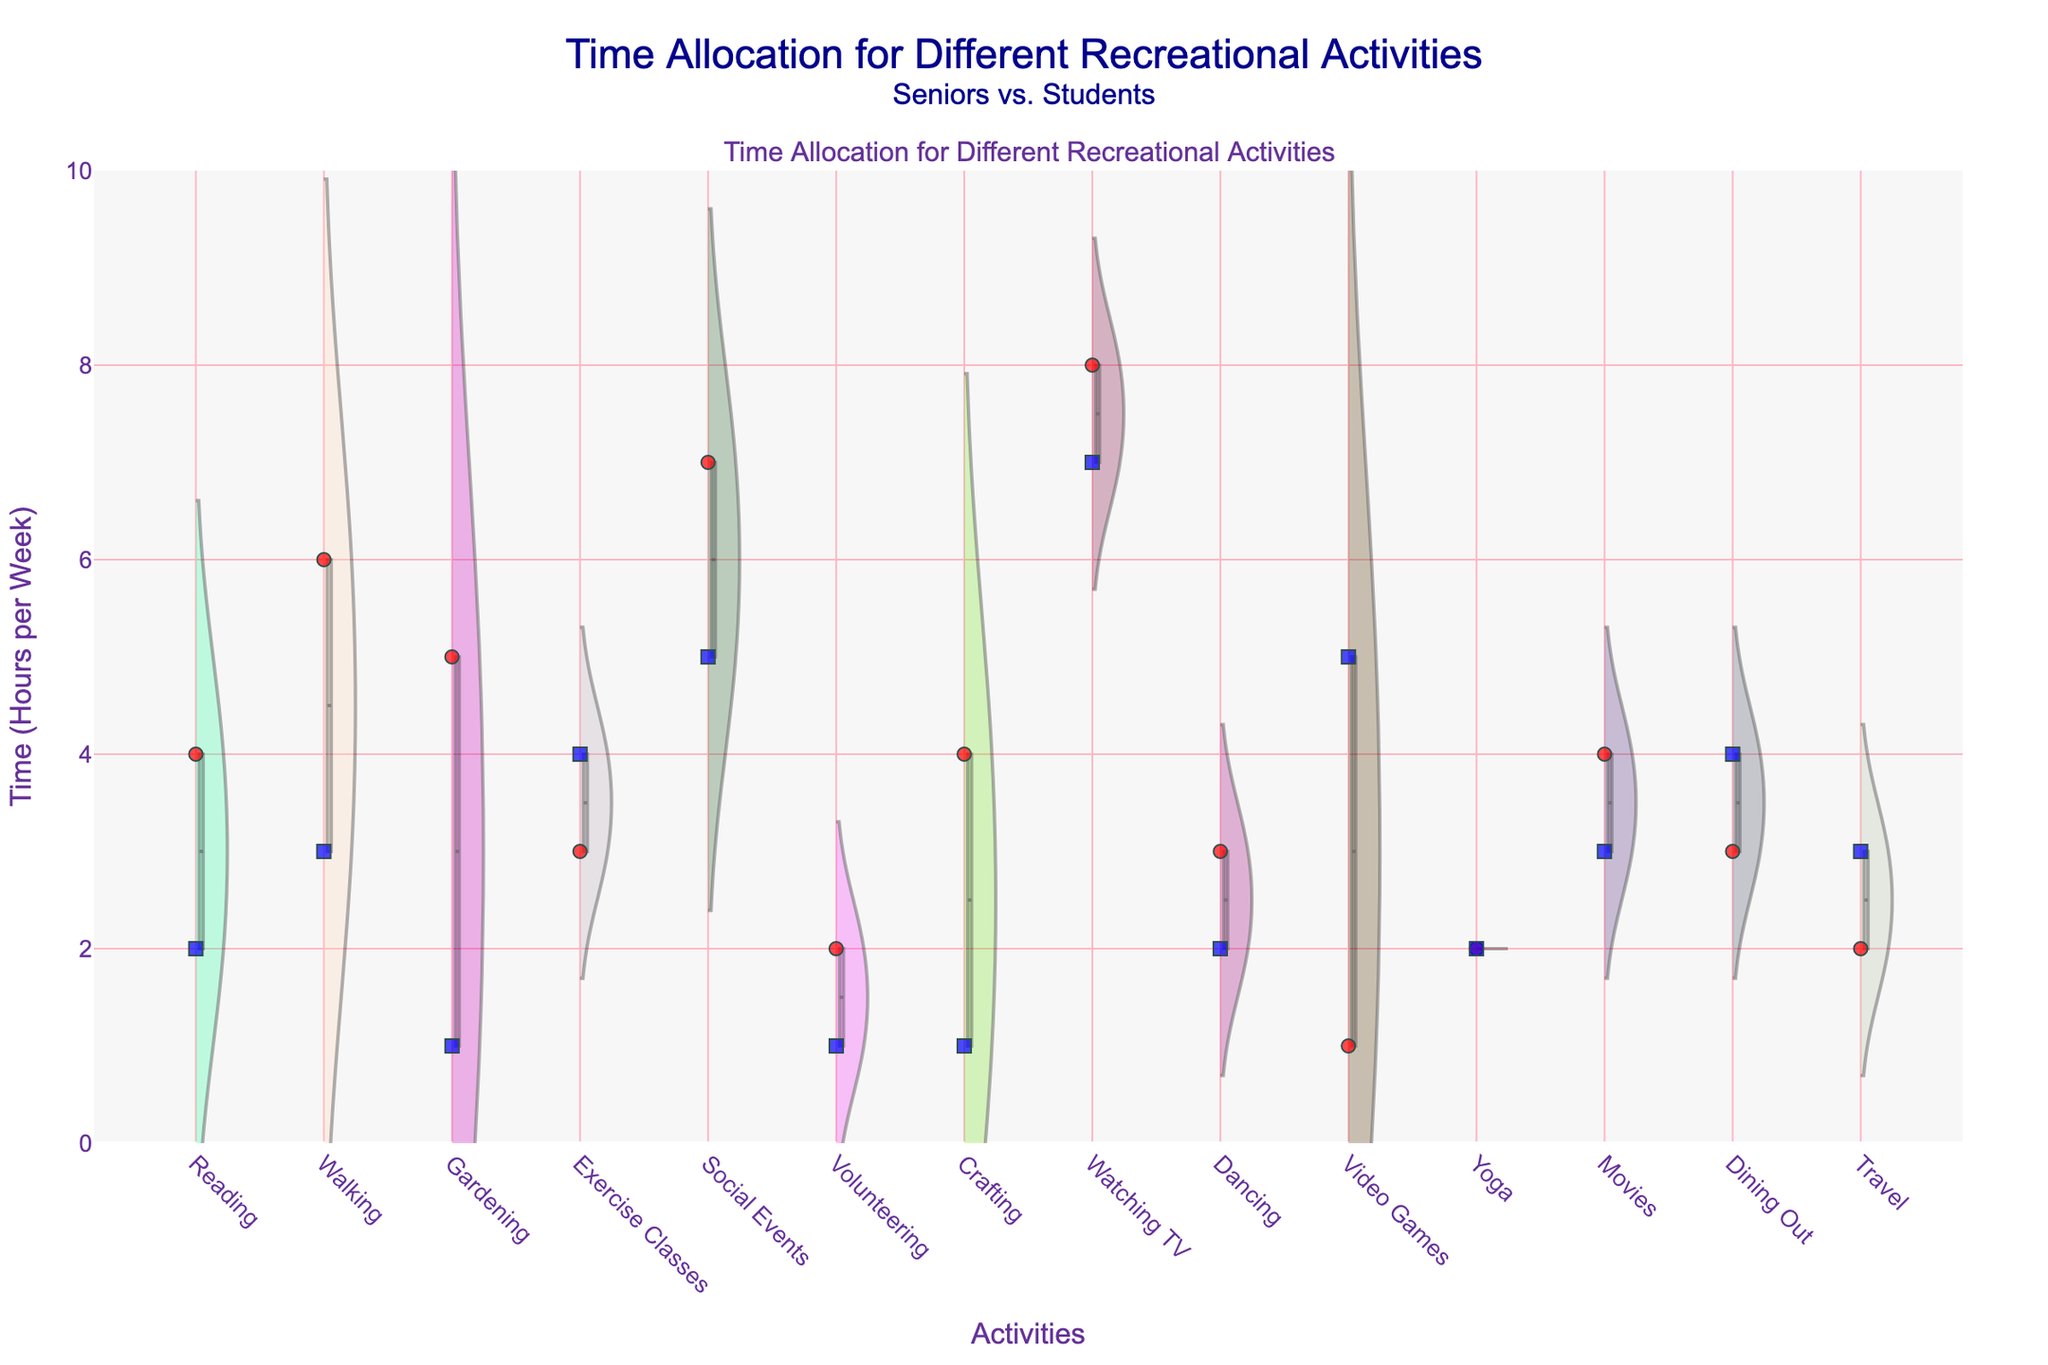Which activity do seniors spend the most time on, on average? From the violin plot, we can observe the different densities for each activity. By looking at the general shape and peaks, we see that seniors spend the most time on watching TV.
Answer: Watching TV Which group spends more time on social events, seniors or students? By comparing the jittered points and the violin densities, it's clear that seniors spend more time in social events compared to students, as most of their points are higher on the y-axis.
Answer: Seniors What is the average time spent by students on video games? The jittered points within the violin plot for students on video games show the average time at 5 hours per week, as they are centered around that value.
Answer: 5 hours per week How does the time spent on walking differ between seniors and students? By examining the violin plot for walking, we see that seniors have a higher density and their jittered points are generally at the 6-hour mark. In comparison, students mostly have points around 3 hours.
Answer: Seniors spend 3 more hours per week What recreational activity do both seniors and students spend an equal amount of time on? The violin plot for yoga shows that both seniors and students have jittered points centered at the same value, 2 hours per week.
Answer: Yoga Which group has a more varied range of time spent on dining out? By observing the spread of the points and the width of the violin plot for dining out, students have a broader distribution indicating more variability in their time spent compared to seniors.
Answer: Students Which activity shows a higher average time spent by seniors compared to students where the difference is more than 2 hours? We compare each activity's averages shown by the violin plots and jittered points. Reading and gardening both have more than a 2-hour difference where seniors spend more time.
Answer: Reading and gardening What is the range of time spent by seniors on exercise classes? The violin plot for exercise classes shows that the density covers approximately 3 hours for seniors along the y-axis, from about 2 to 4 hours.
Answer: 2 to 4 hours Which activity has almost equal time allocation between seniors and students with a slight difference? The activities with similar average times can be determined by their violin plots and points being close. Dining out slightly favors students but is nearly equal.
Answer: Dining out How does the participation in volunteer activities compare between seniors and students? The jittered points for volunteering show that seniors participate more, with 2 hours compared to students' 1 hour. The violin plot confirms this with higher densities for seniors.
Answer: Seniors 